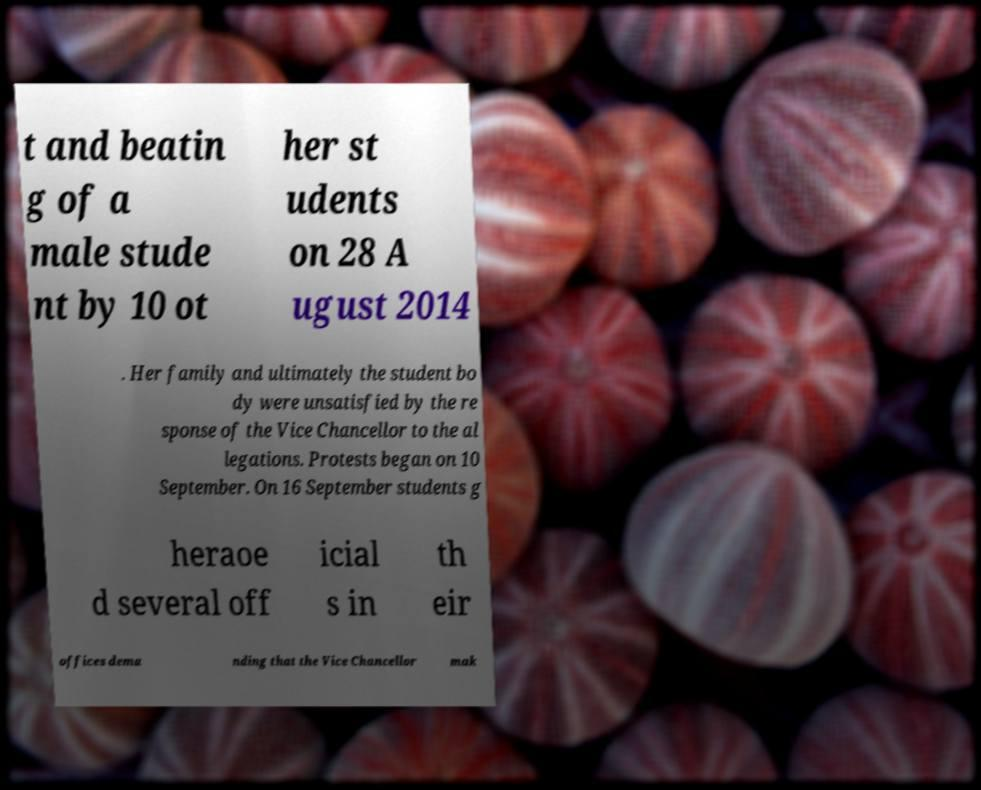I need the written content from this picture converted into text. Can you do that? t and beatin g of a male stude nt by 10 ot her st udents on 28 A ugust 2014 . Her family and ultimately the student bo dy were unsatisfied by the re sponse of the Vice Chancellor to the al legations. Protests began on 10 September. On 16 September students g heraoe d several off icial s in th eir offices dema nding that the Vice Chancellor mak 